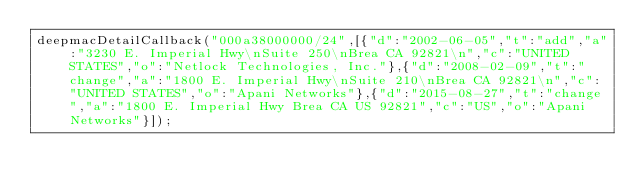Convert code to text. <code><loc_0><loc_0><loc_500><loc_500><_JavaScript_>deepmacDetailCallback("000a38000000/24",[{"d":"2002-06-05","t":"add","a":"3230 E. Imperial Hwy\nSuite 250\nBrea CA 92821\n","c":"UNITED STATES","o":"Netlock Technologies, Inc."},{"d":"2008-02-09","t":"change","a":"1800 E. Imperial Hwy\nSuite 210\nBrea CA 92821\n","c":"UNITED STATES","o":"Apani Networks"},{"d":"2015-08-27","t":"change","a":"1800 E. Imperial Hwy Brea CA US 92821","c":"US","o":"Apani Networks"}]);
</code> 